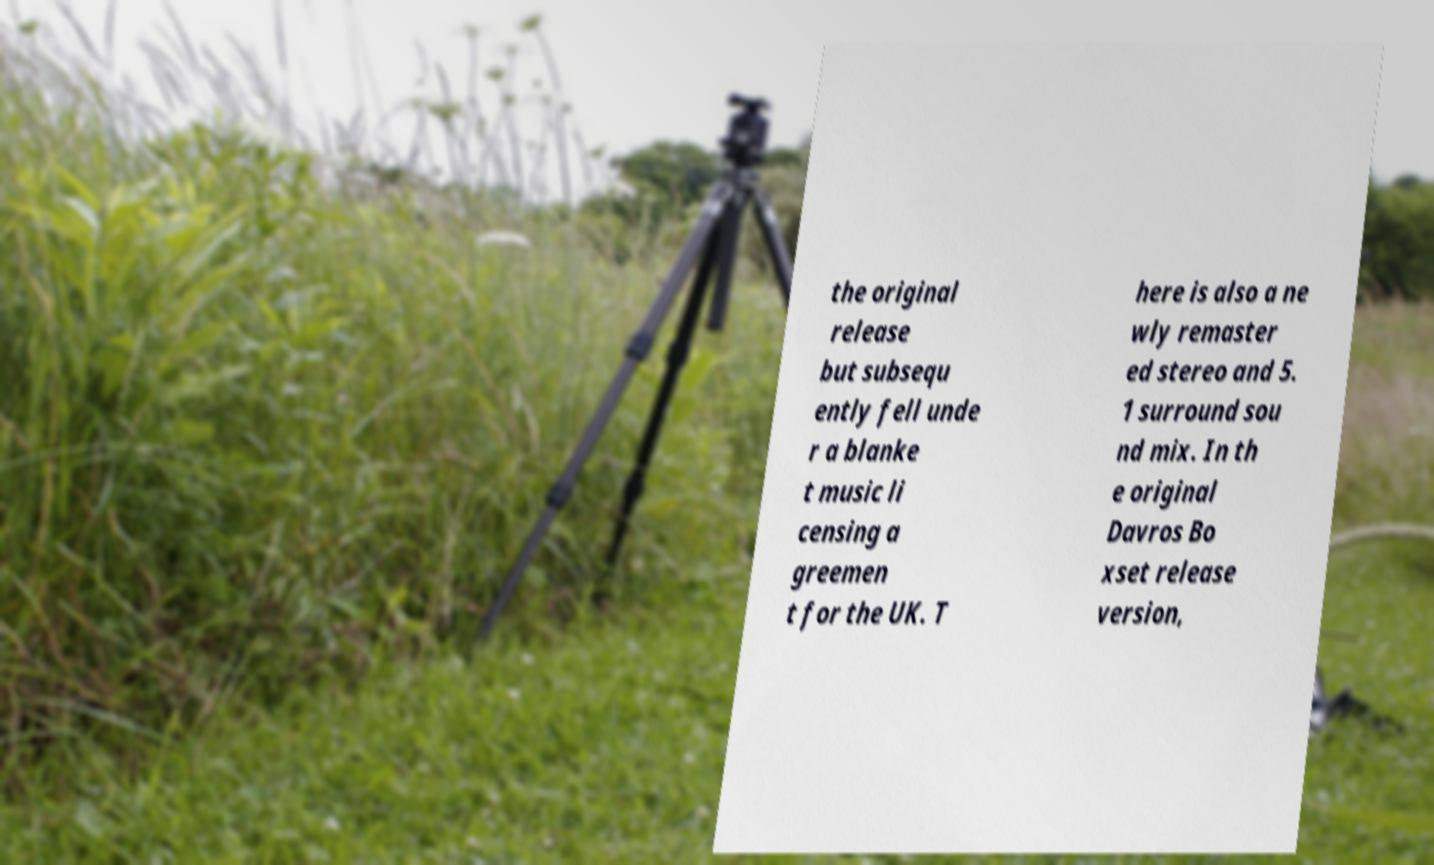Could you assist in decoding the text presented in this image and type it out clearly? the original release but subsequ ently fell unde r a blanke t music li censing a greemen t for the UK. T here is also a ne wly remaster ed stereo and 5. 1 surround sou nd mix. In th e original Davros Bo xset release version, 